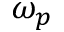Convert formula to latex. <formula><loc_0><loc_0><loc_500><loc_500>\omega _ { p }</formula> 